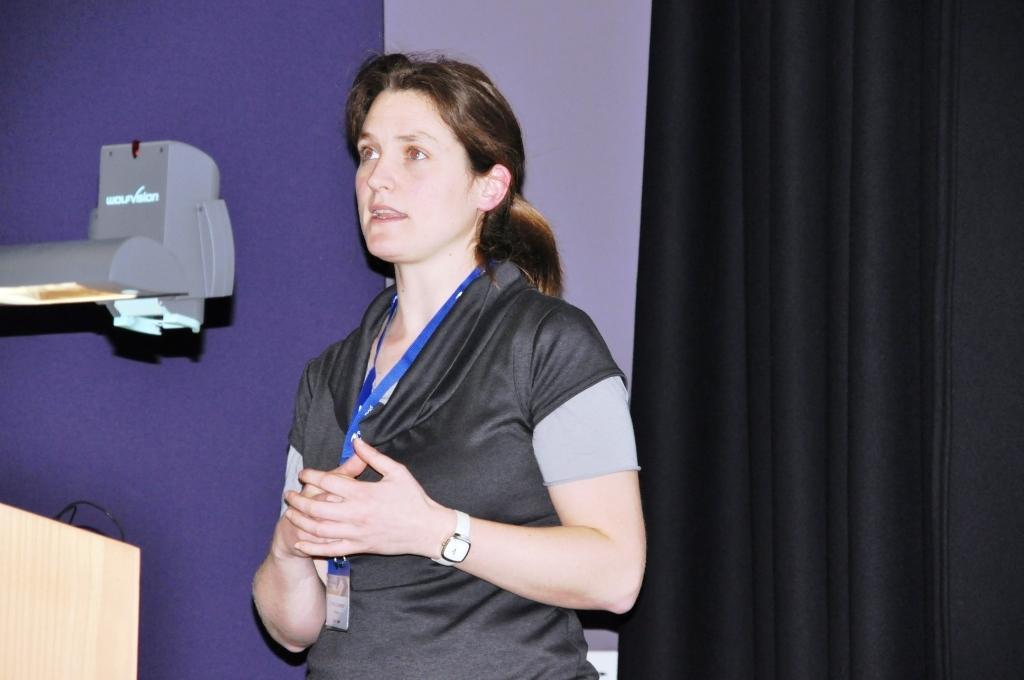Describe this image in one or two sentences. In this picture there is a woman standing and talking. On the left side of the image there is a wire on the podium and there is a light and device. At the back there is a curtain. 